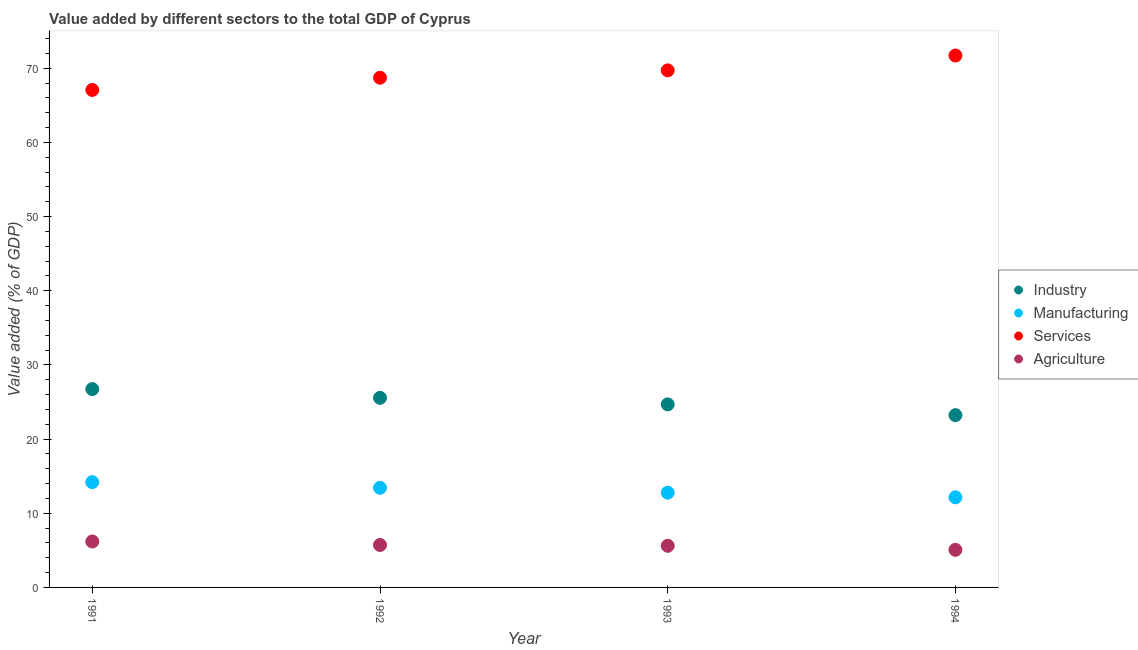Is the number of dotlines equal to the number of legend labels?
Provide a short and direct response. Yes. What is the value added by services sector in 1991?
Your answer should be compact. 67.07. Across all years, what is the maximum value added by services sector?
Provide a short and direct response. 71.71. Across all years, what is the minimum value added by manufacturing sector?
Keep it short and to the point. 12.15. In which year was the value added by services sector minimum?
Your response must be concise. 1991. What is the total value added by industrial sector in the graph?
Make the answer very short. 100.21. What is the difference between the value added by services sector in 1991 and that in 1992?
Your response must be concise. -1.65. What is the difference between the value added by agricultural sector in 1994 and the value added by manufacturing sector in 1993?
Offer a terse response. -7.71. What is the average value added by industrial sector per year?
Make the answer very short. 25.05. In the year 1992, what is the difference between the value added by manufacturing sector and value added by industrial sector?
Provide a succinct answer. -12.12. In how many years, is the value added by manufacturing sector greater than 6 %?
Your response must be concise. 4. What is the ratio of the value added by manufacturing sector in 1991 to that in 1993?
Give a very brief answer. 1.11. Is the difference between the value added by industrial sector in 1991 and 1992 greater than the difference between the value added by agricultural sector in 1991 and 1992?
Make the answer very short. Yes. What is the difference between the highest and the second highest value added by industrial sector?
Give a very brief answer. 1.18. What is the difference between the highest and the lowest value added by services sector?
Offer a terse response. 4.64. Is the sum of the value added by services sector in 1991 and 1994 greater than the maximum value added by agricultural sector across all years?
Your answer should be compact. Yes. Is it the case that in every year, the sum of the value added by agricultural sector and value added by industrial sector is greater than the sum of value added by services sector and value added by manufacturing sector?
Make the answer very short. Yes. Is it the case that in every year, the sum of the value added by industrial sector and value added by manufacturing sector is greater than the value added by services sector?
Ensure brevity in your answer.  No. Is the value added by industrial sector strictly greater than the value added by services sector over the years?
Give a very brief answer. No. How many years are there in the graph?
Keep it short and to the point. 4. What is the difference between two consecutive major ticks on the Y-axis?
Offer a terse response. 10. Are the values on the major ticks of Y-axis written in scientific E-notation?
Offer a terse response. No. Where does the legend appear in the graph?
Your response must be concise. Center right. How are the legend labels stacked?
Ensure brevity in your answer.  Vertical. What is the title of the graph?
Ensure brevity in your answer.  Value added by different sectors to the total GDP of Cyprus. What is the label or title of the X-axis?
Keep it short and to the point. Year. What is the label or title of the Y-axis?
Provide a succinct answer. Value added (% of GDP). What is the Value added (% of GDP) in Industry in 1991?
Your answer should be compact. 26.74. What is the Value added (% of GDP) in Manufacturing in 1991?
Your response must be concise. 14.2. What is the Value added (% of GDP) of Services in 1991?
Your answer should be very brief. 67.07. What is the Value added (% of GDP) of Agriculture in 1991?
Give a very brief answer. 6.19. What is the Value added (% of GDP) of Industry in 1992?
Provide a short and direct response. 25.56. What is the Value added (% of GDP) in Manufacturing in 1992?
Keep it short and to the point. 13.44. What is the Value added (% of GDP) of Services in 1992?
Your answer should be very brief. 68.72. What is the Value added (% of GDP) in Agriculture in 1992?
Your answer should be compact. 5.72. What is the Value added (% of GDP) of Industry in 1993?
Your answer should be very brief. 24.68. What is the Value added (% of GDP) of Manufacturing in 1993?
Your answer should be very brief. 12.77. What is the Value added (% of GDP) in Services in 1993?
Your answer should be compact. 69.71. What is the Value added (% of GDP) in Agriculture in 1993?
Keep it short and to the point. 5.61. What is the Value added (% of GDP) in Industry in 1994?
Offer a very short reply. 23.23. What is the Value added (% of GDP) of Manufacturing in 1994?
Your response must be concise. 12.15. What is the Value added (% of GDP) in Services in 1994?
Offer a very short reply. 71.71. What is the Value added (% of GDP) in Agriculture in 1994?
Provide a short and direct response. 5.07. Across all years, what is the maximum Value added (% of GDP) in Industry?
Give a very brief answer. 26.74. Across all years, what is the maximum Value added (% of GDP) in Manufacturing?
Ensure brevity in your answer.  14.2. Across all years, what is the maximum Value added (% of GDP) in Services?
Your answer should be very brief. 71.71. Across all years, what is the maximum Value added (% of GDP) in Agriculture?
Give a very brief answer. 6.19. Across all years, what is the minimum Value added (% of GDP) in Industry?
Provide a succinct answer. 23.23. Across all years, what is the minimum Value added (% of GDP) in Manufacturing?
Your response must be concise. 12.15. Across all years, what is the minimum Value added (% of GDP) of Services?
Offer a terse response. 67.07. Across all years, what is the minimum Value added (% of GDP) in Agriculture?
Provide a succinct answer. 5.07. What is the total Value added (% of GDP) of Industry in the graph?
Your answer should be very brief. 100.21. What is the total Value added (% of GDP) of Manufacturing in the graph?
Ensure brevity in your answer.  52.56. What is the total Value added (% of GDP) of Services in the graph?
Offer a terse response. 277.2. What is the total Value added (% of GDP) of Agriculture in the graph?
Your answer should be very brief. 22.6. What is the difference between the Value added (% of GDP) of Industry in 1991 and that in 1992?
Keep it short and to the point. 1.18. What is the difference between the Value added (% of GDP) of Manufacturing in 1991 and that in 1992?
Make the answer very short. 0.76. What is the difference between the Value added (% of GDP) in Services in 1991 and that in 1992?
Your response must be concise. -1.65. What is the difference between the Value added (% of GDP) of Agriculture in 1991 and that in 1992?
Provide a succinct answer. 0.47. What is the difference between the Value added (% of GDP) in Industry in 1991 and that in 1993?
Offer a very short reply. 2.06. What is the difference between the Value added (% of GDP) of Manufacturing in 1991 and that in 1993?
Keep it short and to the point. 1.43. What is the difference between the Value added (% of GDP) of Services in 1991 and that in 1993?
Offer a very short reply. -2.64. What is the difference between the Value added (% of GDP) in Agriculture in 1991 and that in 1993?
Your answer should be compact. 0.58. What is the difference between the Value added (% of GDP) in Industry in 1991 and that in 1994?
Ensure brevity in your answer.  3.51. What is the difference between the Value added (% of GDP) of Manufacturing in 1991 and that in 1994?
Your answer should be compact. 2.05. What is the difference between the Value added (% of GDP) of Services in 1991 and that in 1994?
Make the answer very short. -4.64. What is the difference between the Value added (% of GDP) in Agriculture in 1991 and that in 1994?
Keep it short and to the point. 1.12. What is the difference between the Value added (% of GDP) of Industry in 1992 and that in 1993?
Give a very brief answer. 0.88. What is the difference between the Value added (% of GDP) of Manufacturing in 1992 and that in 1993?
Give a very brief answer. 0.66. What is the difference between the Value added (% of GDP) in Services in 1992 and that in 1993?
Your response must be concise. -0.99. What is the difference between the Value added (% of GDP) in Agriculture in 1992 and that in 1993?
Your answer should be very brief. 0.11. What is the difference between the Value added (% of GDP) in Industry in 1992 and that in 1994?
Provide a short and direct response. 2.33. What is the difference between the Value added (% of GDP) in Manufacturing in 1992 and that in 1994?
Provide a short and direct response. 1.29. What is the difference between the Value added (% of GDP) in Services in 1992 and that in 1994?
Your response must be concise. -2.99. What is the difference between the Value added (% of GDP) of Agriculture in 1992 and that in 1994?
Offer a terse response. 0.66. What is the difference between the Value added (% of GDP) of Industry in 1993 and that in 1994?
Provide a short and direct response. 1.45. What is the difference between the Value added (% of GDP) in Manufacturing in 1993 and that in 1994?
Give a very brief answer. 0.63. What is the difference between the Value added (% of GDP) in Services in 1993 and that in 1994?
Make the answer very short. -2. What is the difference between the Value added (% of GDP) in Agriculture in 1993 and that in 1994?
Your response must be concise. 0.55. What is the difference between the Value added (% of GDP) of Industry in 1991 and the Value added (% of GDP) of Manufacturing in 1992?
Provide a succinct answer. 13.3. What is the difference between the Value added (% of GDP) in Industry in 1991 and the Value added (% of GDP) in Services in 1992?
Your answer should be very brief. -41.98. What is the difference between the Value added (% of GDP) in Industry in 1991 and the Value added (% of GDP) in Agriculture in 1992?
Offer a terse response. 21.02. What is the difference between the Value added (% of GDP) of Manufacturing in 1991 and the Value added (% of GDP) of Services in 1992?
Make the answer very short. -54.52. What is the difference between the Value added (% of GDP) of Manufacturing in 1991 and the Value added (% of GDP) of Agriculture in 1992?
Your answer should be compact. 8.48. What is the difference between the Value added (% of GDP) in Services in 1991 and the Value added (% of GDP) in Agriculture in 1992?
Provide a short and direct response. 61.35. What is the difference between the Value added (% of GDP) in Industry in 1991 and the Value added (% of GDP) in Manufacturing in 1993?
Keep it short and to the point. 13.97. What is the difference between the Value added (% of GDP) of Industry in 1991 and the Value added (% of GDP) of Services in 1993?
Provide a short and direct response. -42.97. What is the difference between the Value added (% of GDP) of Industry in 1991 and the Value added (% of GDP) of Agriculture in 1993?
Keep it short and to the point. 21.13. What is the difference between the Value added (% of GDP) of Manufacturing in 1991 and the Value added (% of GDP) of Services in 1993?
Offer a very short reply. -55.51. What is the difference between the Value added (% of GDP) of Manufacturing in 1991 and the Value added (% of GDP) of Agriculture in 1993?
Your answer should be compact. 8.59. What is the difference between the Value added (% of GDP) of Services in 1991 and the Value added (% of GDP) of Agriculture in 1993?
Your answer should be very brief. 61.46. What is the difference between the Value added (% of GDP) of Industry in 1991 and the Value added (% of GDP) of Manufacturing in 1994?
Your answer should be very brief. 14.59. What is the difference between the Value added (% of GDP) of Industry in 1991 and the Value added (% of GDP) of Services in 1994?
Your answer should be compact. -44.97. What is the difference between the Value added (% of GDP) of Industry in 1991 and the Value added (% of GDP) of Agriculture in 1994?
Your answer should be very brief. 21.67. What is the difference between the Value added (% of GDP) in Manufacturing in 1991 and the Value added (% of GDP) in Services in 1994?
Ensure brevity in your answer.  -57.51. What is the difference between the Value added (% of GDP) in Manufacturing in 1991 and the Value added (% of GDP) in Agriculture in 1994?
Ensure brevity in your answer.  9.13. What is the difference between the Value added (% of GDP) in Services in 1991 and the Value added (% of GDP) in Agriculture in 1994?
Provide a short and direct response. 62. What is the difference between the Value added (% of GDP) of Industry in 1992 and the Value added (% of GDP) of Manufacturing in 1993?
Offer a terse response. 12.79. What is the difference between the Value added (% of GDP) of Industry in 1992 and the Value added (% of GDP) of Services in 1993?
Ensure brevity in your answer.  -44.15. What is the difference between the Value added (% of GDP) of Industry in 1992 and the Value added (% of GDP) of Agriculture in 1993?
Make the answer very short. 19.95. What is the difference between the Value added (% of GDP) in Manufacturing in 1992 and the Value added (% of GDP) in Services in 1993?
Ensure brevity in your answer.  -56.27. What is the difference between the Value added (% of GDP) of Manufacturing in 1992 and the Value added (% of GDP) of Agriculture in 1993?
Provide a succinct answer. 7.82. What is the difference between the Value added (% of GDP) in Services in 1992 and the Value added (% of GDP) in Agriculture in 1993?
Keep it short and to the point. 63.1. What is the difference between the Value added (% of GDP) of Industry in 1992 and the Value added (% of GDP) of Manufacturing in 1994?
Give a very brief answer. 13.41. What is the difference between the Value added (% of GDP) in Industry in 1992 and the Value added (% of GDP) in Services in 1994?
Provide a succinct answer. -46.15. What is the difference between the Value added (% of GDP) in Industry in 1992 and the Value added (% of GDP) in Agriculture in 1994?
Your answer should be compact. 20.49. What is the difference between the Value added (% of GDP) in Manufacturing in 1992 and the Value added (% of GDP) in Services in 1994?
Ensure brevity in your answer.  -58.27. What is the difference between the Value added (% of GDP) in Manufacturing in 1992 and the Value added (% of GDP) in Agriculture in 1994?
Give a very brief answer. 8.37. What is the difference between the Value added (% of GDP) in Services in 1992 and the Value added (% of GDP) in Agriculture in 1994?
Make the answer very short. 63.65. What is the difference between the Value added (% of GDP) of Industry in 1993 and the Value added (% of GDP) of Manufacturing in 1994?
Your answer should be compact. 12.53. What is the difference between the Value added (% of GDP) in Industry in 1993 and the Value added (% of GDP) in Services in 1994?
Your response must be concise. -47.03. What is the difference between the Value added (% of GDP) of Industry in 1993 and the Value added (% of GDP) of Agriculture in 1994?
Offer a terse response. 19.61. What is the difference between the Value added (% of GDP) in Manufacturing in 1993 and the Value added (% of GDP) in Services in 1994?
Keep it short and to the point. -58.93. What is the difference between the Value added (% of GDP) of Manufacturing in 1993 and the Value added (% of GDP) of Agriculture in 1994?
Provide a succinct answer. 7.71. What is the difference between the Value added (% of GDP) of Services in 1993 and the Value added (% of GDP) of Agriculture in 1994?
Offer a terse response. 64.64. What is the average Value added (% of GDP) of Industry per year?
Provide a succinct answer. 25.05. What is the average Value added (% of GDP) of Manufacturing per year?
Make the answer very short. 13.14. What is the average Value added (% of GDP) of Services per year?
Your response must be concise. 69.3. What is the average Value added (% of GDP) of Agriculture per year?
Offer a terse response. 5.65. In the year 1991, what is the difference between the Value added (% of GDP) in Industry and Value added (% of GDP) in Manufacturing?
Ensure brevity in your answer.  12.54. In the year 1991, what is the difference between the Value added (% of GDP) of Industry and Value added (% of GDP) of Services?
Your response must be concise. -40.33. In the year 1991, what is the difference between the Value added (% of GDP) in Industry and Value added (% of GDP) in Agriculture?
Offer a terse response. 20.55. In the year 1991, what is the difference between the Value added (% of GDP) of Manufacturing and Value added (% of GDP) of Services?
Ensure brevity in your answer.  -52.87. In the year 1991, what is the difference between the Value added (% of GDP) of Manufacturing and Value added (% of GDP) of Agriculture?
Offer a very short reply. 8.01. In the year 1991, what is the difference between the Value added (% of GDP) of Services and Value added (% of GDP) of Agriculture?
Offer a terse response. 60.88. In the year 1992, what is the difference between the Value added (% of GDP) of Industry and Value added (% of GDP) of Manufacturing?
Your response must be concise. 12.12. In the year 1992, what is the difference between the Value added (% of GDP) of Industry and Value added (% of GDP) of Services?
Provide a succinct answer. -43.16. In the year 1992, what is the difference between the Value added (% of GDP) in Industry and Value added (% of GDP) in Agriculture?
Provide a succinct answer. 19.84. In the year 1992, what is the difference between the Value added (% of GDP) in Manufacturing and Value added (% of GDP) in Services?
Give a very brief answer. -55.28. In the year 1992, what is the difference between the Value added (% of GDP) in Manufacturing and Value added (% of GDP) in Agriculture?
Keep it short and to the point. 7.71. In the year 1992, what is the difference between the Value added (% of GDP) in Services and Value added (% of GDP) in Agriculture?
Keep it short and to the point. 62.99. In the year 1993, what is the difference between the Value added (% of GDP) of Industry and Value added (% of GDP) of Manufacturing?
Ensure brevity in your answer.  11.91. In the year 1993, what is the difference between the Value added (% of GDP) of Industry and Value added (% of GDP) of Services?
Offer a very short reply. -45.03. In the year 1993, what is the difference between the Value added (% of GDP) in Industry and Value added (% of GDP) in Agriculture?
Offer a terse response. 19.07. In the year 1993, what is the difference between the Value added (% of GDP) in Manufacturing and Value added (% of GDP) in Services?
Make the answer very short. -56.93. In the year 1993, what is the difference between the Value added (% of GDP) of Manufacturing and Value added (% of GDP) of Agriculture?
Ensure brevity in your answer.  7.16. In the year 1993, what is the difference between the Value added (% of GDP) of Services and Value added (% of GDP) of Agriculture?
Offer a terse response. 64.09. In the year 1994, what is the difference between the Value added (% of GDP) in Industry and Value added (% of GDP) in Manufacturing?
Offer a terse response. 11.08. In the year 1994, what is the difference between the Value added (% of GDP) in Industry and Value added (% of GDP) in Services?
Ensure brevity in your answer.  -48.48. In the year 1994, what is the difference between the Value added (% of GDP) of Industry and Value added (% of GDP) of Agriculture?
Your answer should be very brief. 18.16. In the year 1994, what is the difference between the Value added (% of GDP) of Manufacturing and Value added (% of GDP) of Services?
Provide a short and direct response. -59.56. In the year 1994, what is the difference between the Value added (% of GDP) in Manufacturing and Value added (% of GDP) in Agriculture?
Your answer should be very brief. 7.08. In the year 1994, what is the difference between the Value added (% of GDP) in Services and Value added (% of GDP) in Agriculture?
Provide a succinct answer. 66.64. What is the ratio of the Value added (% of GDP) of Industry in 1991 to that in 1992?
Give a very brief answer. 1.05. What is the ratio of the Value added (% of GDP) of Manufacturing in 1991 to that in 1992?
Offer a very short reply. 1.06. What is the ratio of the Value added (% of GDP) of Services in 1991 to that in 1992?
Provide a succinct answer. 0.98. What is the ratio of the Value added (% of GDP) of Agriculture in 1991 to that in 1992?
Give a very brief answer. 1.08. What is the ratio of the Value added (% of GDP) in Industry in 1991 to that in 1993?
Ensure brevity in your answer.  1.08. What is the ratio of the Value added (% of GDP) of Manufacturing in 1991 to that in 1993?
Keep it short and to the point. 1.11. What is the ratio of the Value added (% of GDP) of Services in 1991 to that in 1993?
Keep it short and to the point. 0.96. What is the ratio of the Value added (% of GDP) of Agriculture in 1991 to that in 1993?
Provide a succinct answer. 1.1. What is the ratio of the Value added (% of GDP) in Industry in 1991 to that in 1994?
Provide a short and direct response. 1.15. What is the ratio of the Value added (% of GDP) of Manufacturing in 1991 to that in 1994?
Offer a terse response. 1.17. What is the ratio of the Value added (% of GDP) of Services in 1991 to that in 1994?
Your answer should be compact. 0.94. What is the ratio of the Value added (% of GDP) in Agriculture in 1991 to that in 1994?
Keep it short and to the point. 1.22. What is the ratio of the Value added (% of GDP) of Industry in 1992 to that in 1993?
Ensure brevity in your answer.  1.04. What is the ratio of the Value added (% of GDP) of Manufacturing in 1992 to that in 1993?
Give a very brief answer. 1.05. What is the ratio of the Value added (% of GDP) in Services in 1992 to that in 1993?
Make the answer very short. 0.99. What is the ratio of the Value added (% of GDP) of Agriculture in 1992 to that in 1993?
Provide a succinct answer. 1.02. What is the ratio of the Value added (% of GDP) in Industry in 1992 to that in 1994?
Ensure brevity in your answer.  1.1. What is the ratio of the Value added (% of GDP) in Manufacturing in 1992 to that in 1994?
Give a very brief answer. 1.11. What is the ratio of the Value added (% of GDP) of Services in 1992 to that in 1994?
Offer a terse response. 0.96. What is the ratio of the Value added (% of GDP) of Agriculture in 1992 to that in 1994?
Keep it short and to the point. 1.13. What is the ratio of the Value added (% of GDP) in Industry in 1993 to that in 1994?
Make the answer very short. 1.06. What is the ratio of the Value added (% of GDP) of Manufacturing in 1993 to that in 1994?
Offer a very short reply. 1.05. What is the ratio of the Value added (% of GDP) in Services in 1993 to that in 1994?
Your response must be concise. 0.97. What is the ratio of the Value added (% of GDP) of Agriculture in 1993 to that in 1994?
Ensure brevity in your answer.  1.11. What is the difference between the highest and the second highest Value added (% of GDP) of Industry?
Your answer should be compact. 1.18. What is the difference between the highest and the second highest Value added (% of GDP) of Manufacturing?
Provide a short and direct response. 0.76. What is the difference between the highest and the second highest Value added (% of GDP) of Services?
Ensure brevity in your answer.  2. What is the difference between the highest and the second highest Value added (% of GDP) of Agriculture?
Offer a very short reply. 0.47. What is the difference between the highest and the lowest Value added (% of GDP) in Industry?
Your answer should be compact. 3.51. What is the difference between the highest and the lowest Value added (% of GDP) in Manufacturing?
Offer a terse response. 2.05. What is the difference between the highest and the lowest Value added (% of GDP) of Services?
Offer a terse response. 4.64. What is the difference between the highest and the lowest Value added (% of GDP) in Agriculture?
Offer a terse response. 1.12. 